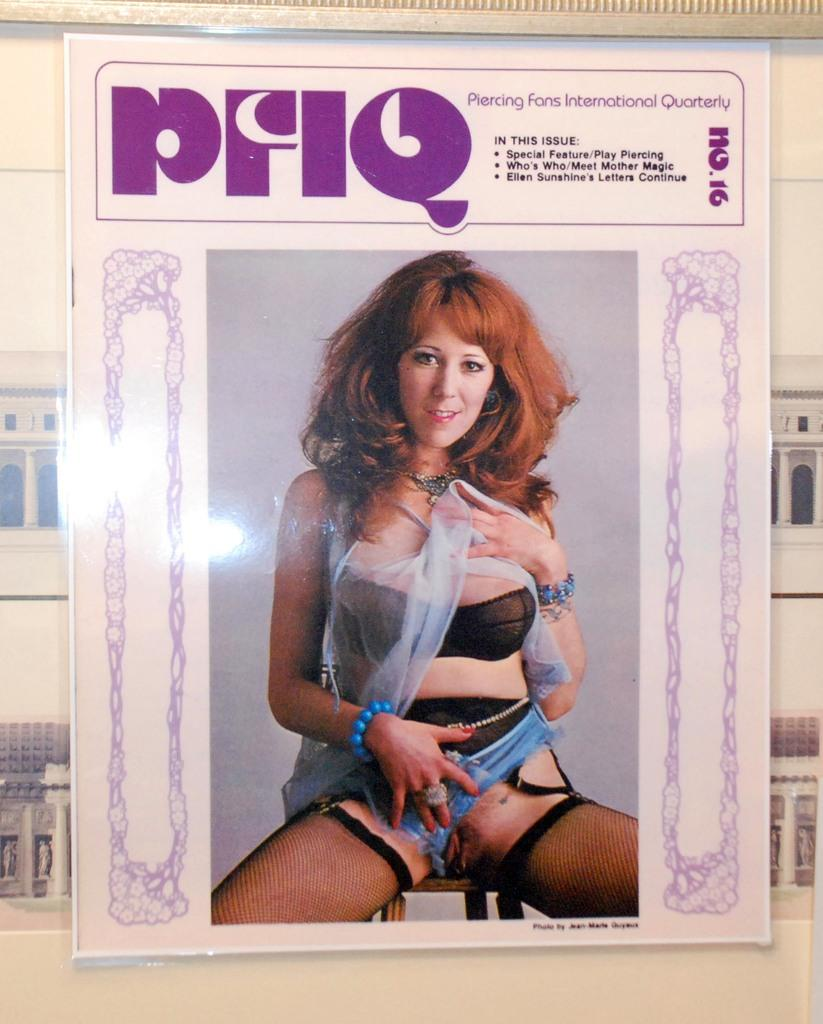What is on the wall in the image? There is a poster on the wall in the image. What type of disease is depicted on the poster in the image? There is no disease depicted on the poster in the image, as the fact provided does not mention any specific content or theme of the poster. 